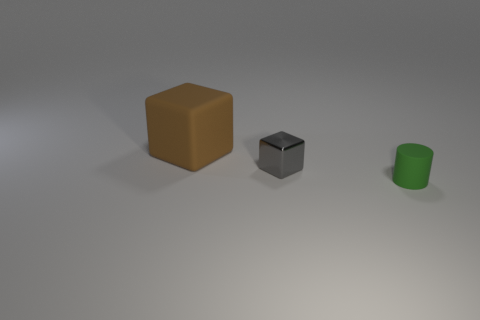Add 1 small gray cubes. How many objects exist? 4 Subtract all cylinders. How many objects are left? 2 Add 3 tiny blue rubber objects. How many tiny blue rubber objects exist? 3 Subtract 0 red blocks. How many objects are left? 3 Subtract all red things. Subtract all tiny rubber objects. How many objects are left? 2 Add 1 gray metallic blocks. How many gray metallic blocks are left? 2 